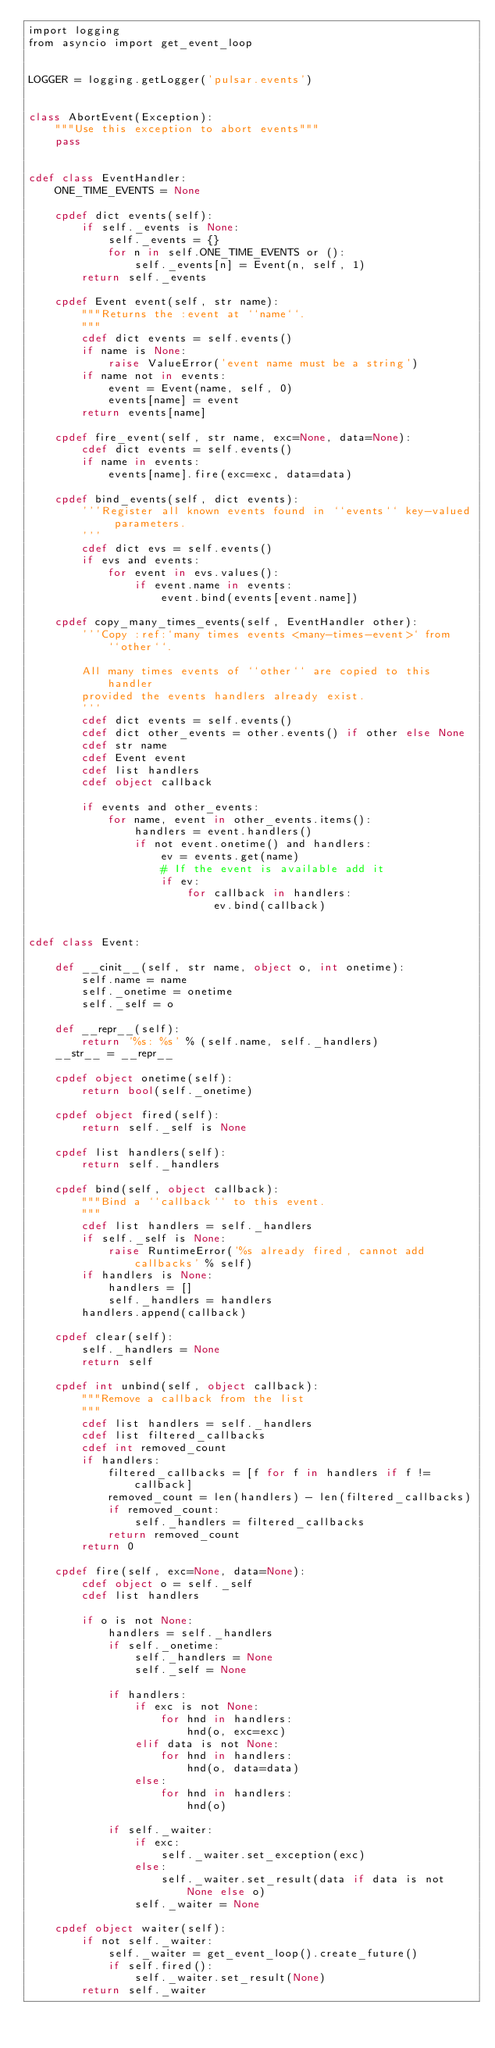<code> <loc_0><loc_0><loc_500><loc_500><_Cython_>import logging
from asyncio import get_event_loop


LOGGER = logging.getLogger('pulsar.events')


class AbortEvent(Exception):
    """Use this exception to abort events"""
    pass


cdef class EventHandler:
    ONE_TIME_EVENTS = None

    cpdef dict events(self):
        if self._events is None:
            self._events = {}
            for n in self.ONE_TIME_EVENTS or ():
                self._events[n] = Event(n, self, 1)
        return self._events

    cpdef Event event(self, str name):
        """Returns the :event at ``name``.
        """
        cdef dict events = self.events()
        if name is None:
            raise ValueError('event name must be a string')
        if name not in events:
            event = Event(name, self, 0)
            events[name] = event
        return events[name]

    cpdef fire_event(self, str name, exc=None, data=None):
        cdef dict events = self.events()
        if name in events:
            events[name].fire(exc=exc, data=data)

    cpdef bind_events(self, dict events):
        '''Register all known events found in ``events`` key-valued parameters.
        '''
        cdef dict evs = self.events()
        if evs and events:
            for event in evs.values():
                if event.name in events:
                    event.bind(events[event.name])

    cpdef copy_many_times_events(self, EventHandler other):
        '''Copy :ref:`many times events <many-times-event>` from  ``other``.

        All many times events of ``other`` are copied to this handler
        provided the events handlers already exist.
        '''
        cdef dict events = self.events()
        cdef dict other_events = other.events() if other else None
        cdef str name
        cdef Event event
        cdef list handlers
        cdef object callback

        if events and other_events:
            for name, event in other_events.items():
                handlers = event.handlers()
                if not event.onetime() and handlers:
                    ev = events.get(name)
                    # If the event is available add it
                    if ev:
                        for callback in handlers:
                            ev.bind(callback)


cdef class Event:

    def __cinit__(self, str name, object o, int onetime):
        self.name = name
        self._onetime = onetime
        self._self = o

    def __repr__(self):
        return '%s: %s' % (self.name, self._handlers)
    __str__ = __repr__

    cpdef object onetime(self):
        return bool(self._onetime)

    cpdef object fired(self):
        return self._self is None

    cpdef list handlers(self):
        return self._handlers

    cpdef bind(self, object callback):
        """Bind a ``callback`` to this event.
        """
        cdef list handlers = self._handlers
        if self._self is None:
            raise RuntimeError('%s already fired, cannot add callbacks' % self)
        if handlers is None:
            handlers = []
            self._handlers = handlers
        handlers.append(callback)

    cpdef clear(self):
        self._handlers = None
        return self

    cpdef int unbind(self, object callback):
        """Remove a callback from the list
        """
        cdef list handlers = self._handlers
        cdef list filtered_callbacks
        cdef int removed_count
        if handlers:
            filtered_callbacks = [f for f in handlers if f != callback]
            removed_count = len(handlers) - len(filtered_callbacks)
            if removed_count:
                self._handlers = filtered_callbacks
            return removed_count
        return 0

    cpdef fire(self, exc=None, data=None):
        cdef object o = self._self
        cdef list handlers

        if o is not None:
            handlers = self._handlers
            if self._onetime:
                self._handlers = None
                self._self = None

            if handlers:
                if exc is not None:
                    for hnd in handlers:
                        hnd(o, exc=exc)
                elif data is not None:
                    for hnd in handlers:
                        hnd(o, data=data)
                else:
                    for hnd in handlers:
                        hnd(o)

            if self._waiter:
                if exc:
                    self._waiter.set_exception(exc)
                else:
                    self._waiter.set_result(data if data is not None else o)
                self._waiter = None

    cpdef object waiter(self):
        if not self._waiter:
            self._waiter = get_event_loop().create_future()
            if self.fired():
                self._waiter.set_result(None)
        return self._waiter
</code> 